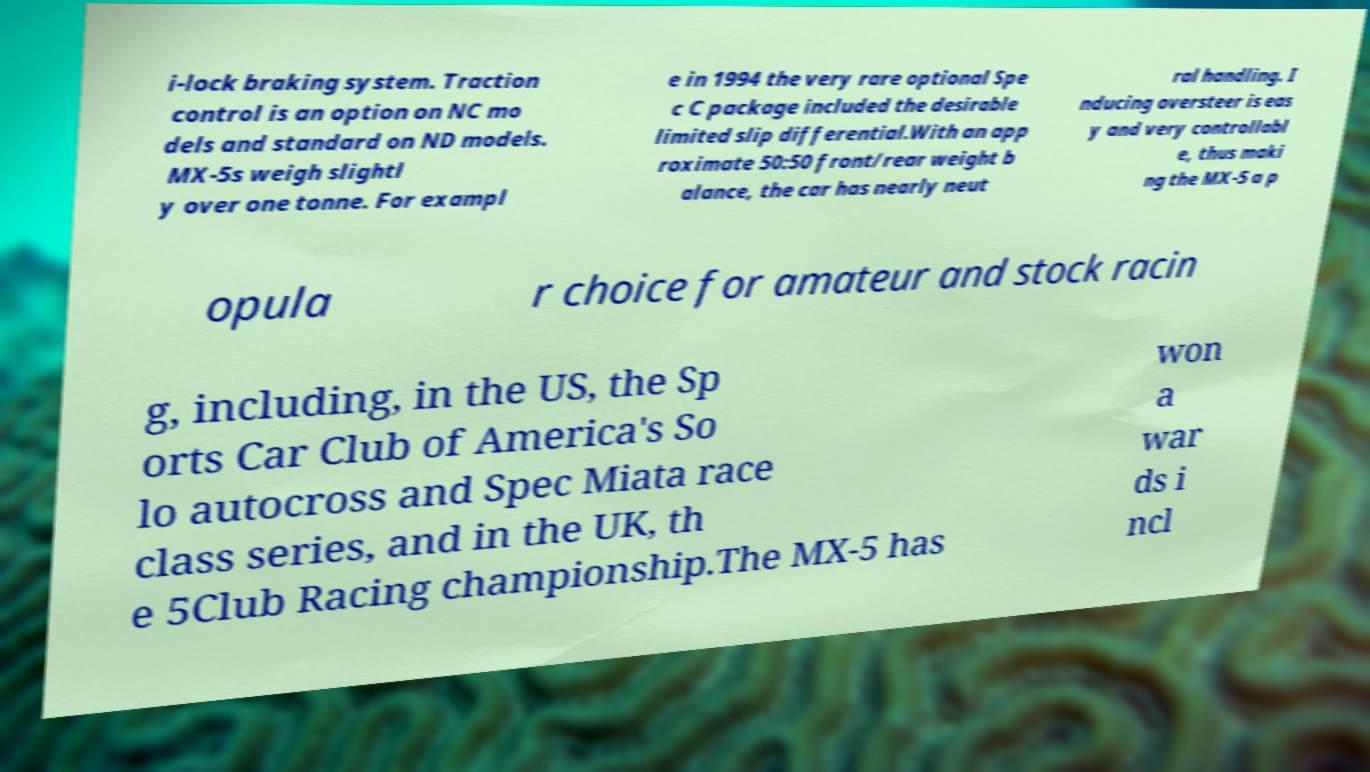There's text embedded in this image that I need extracted. Can you transcribe it verbatim? i-lock braking system. Traction control is an option on NC mo dels and standard on ND models. MX-5s weigh slightl y over one tonne. For exampl e in 1994 the very rare optional Spe c C package included the desirable limited slip differential.With an app roximate 50:50 front/rear weight b alance, the car has nearly neut ral handling. I nducing oversteer is eas y and very controllabl e, thus maki ng the MX-5 a p opula r choice for amateur and stock racin g, including, in the US, the Sp orts Car Club of America's So lo autocross and Spec Miata race class series, and in the UK, th e 5Club Racing championship.The MX-5 has won a war ds i ncl 